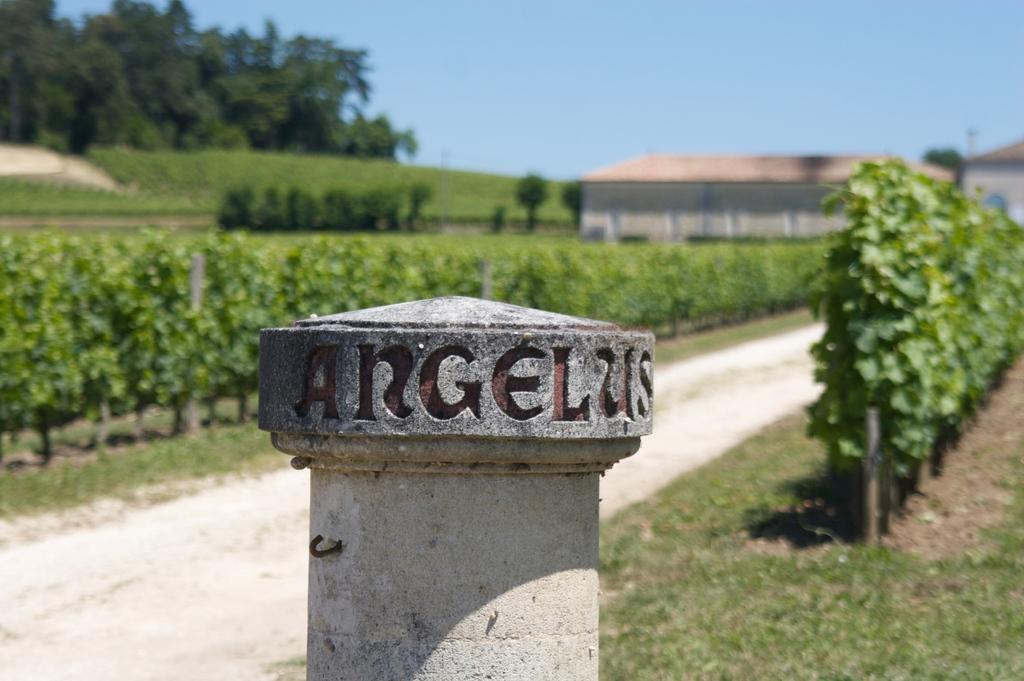Could you give a brief overview of what you see in this image? In this image, we can see a pole with some text. We can see some plants. We can see the ground. We can see some grass. There are a few trees, houses. We can see the sky. 